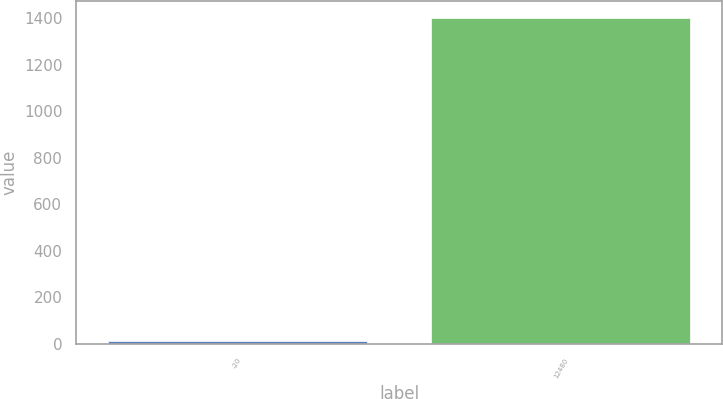<chart> <loc_0><loc_0><loc_500><loc_500><bar_chart><fcel>-20<fcel>12480<nl><fcel>10<fcel>1404<nl></chart> 